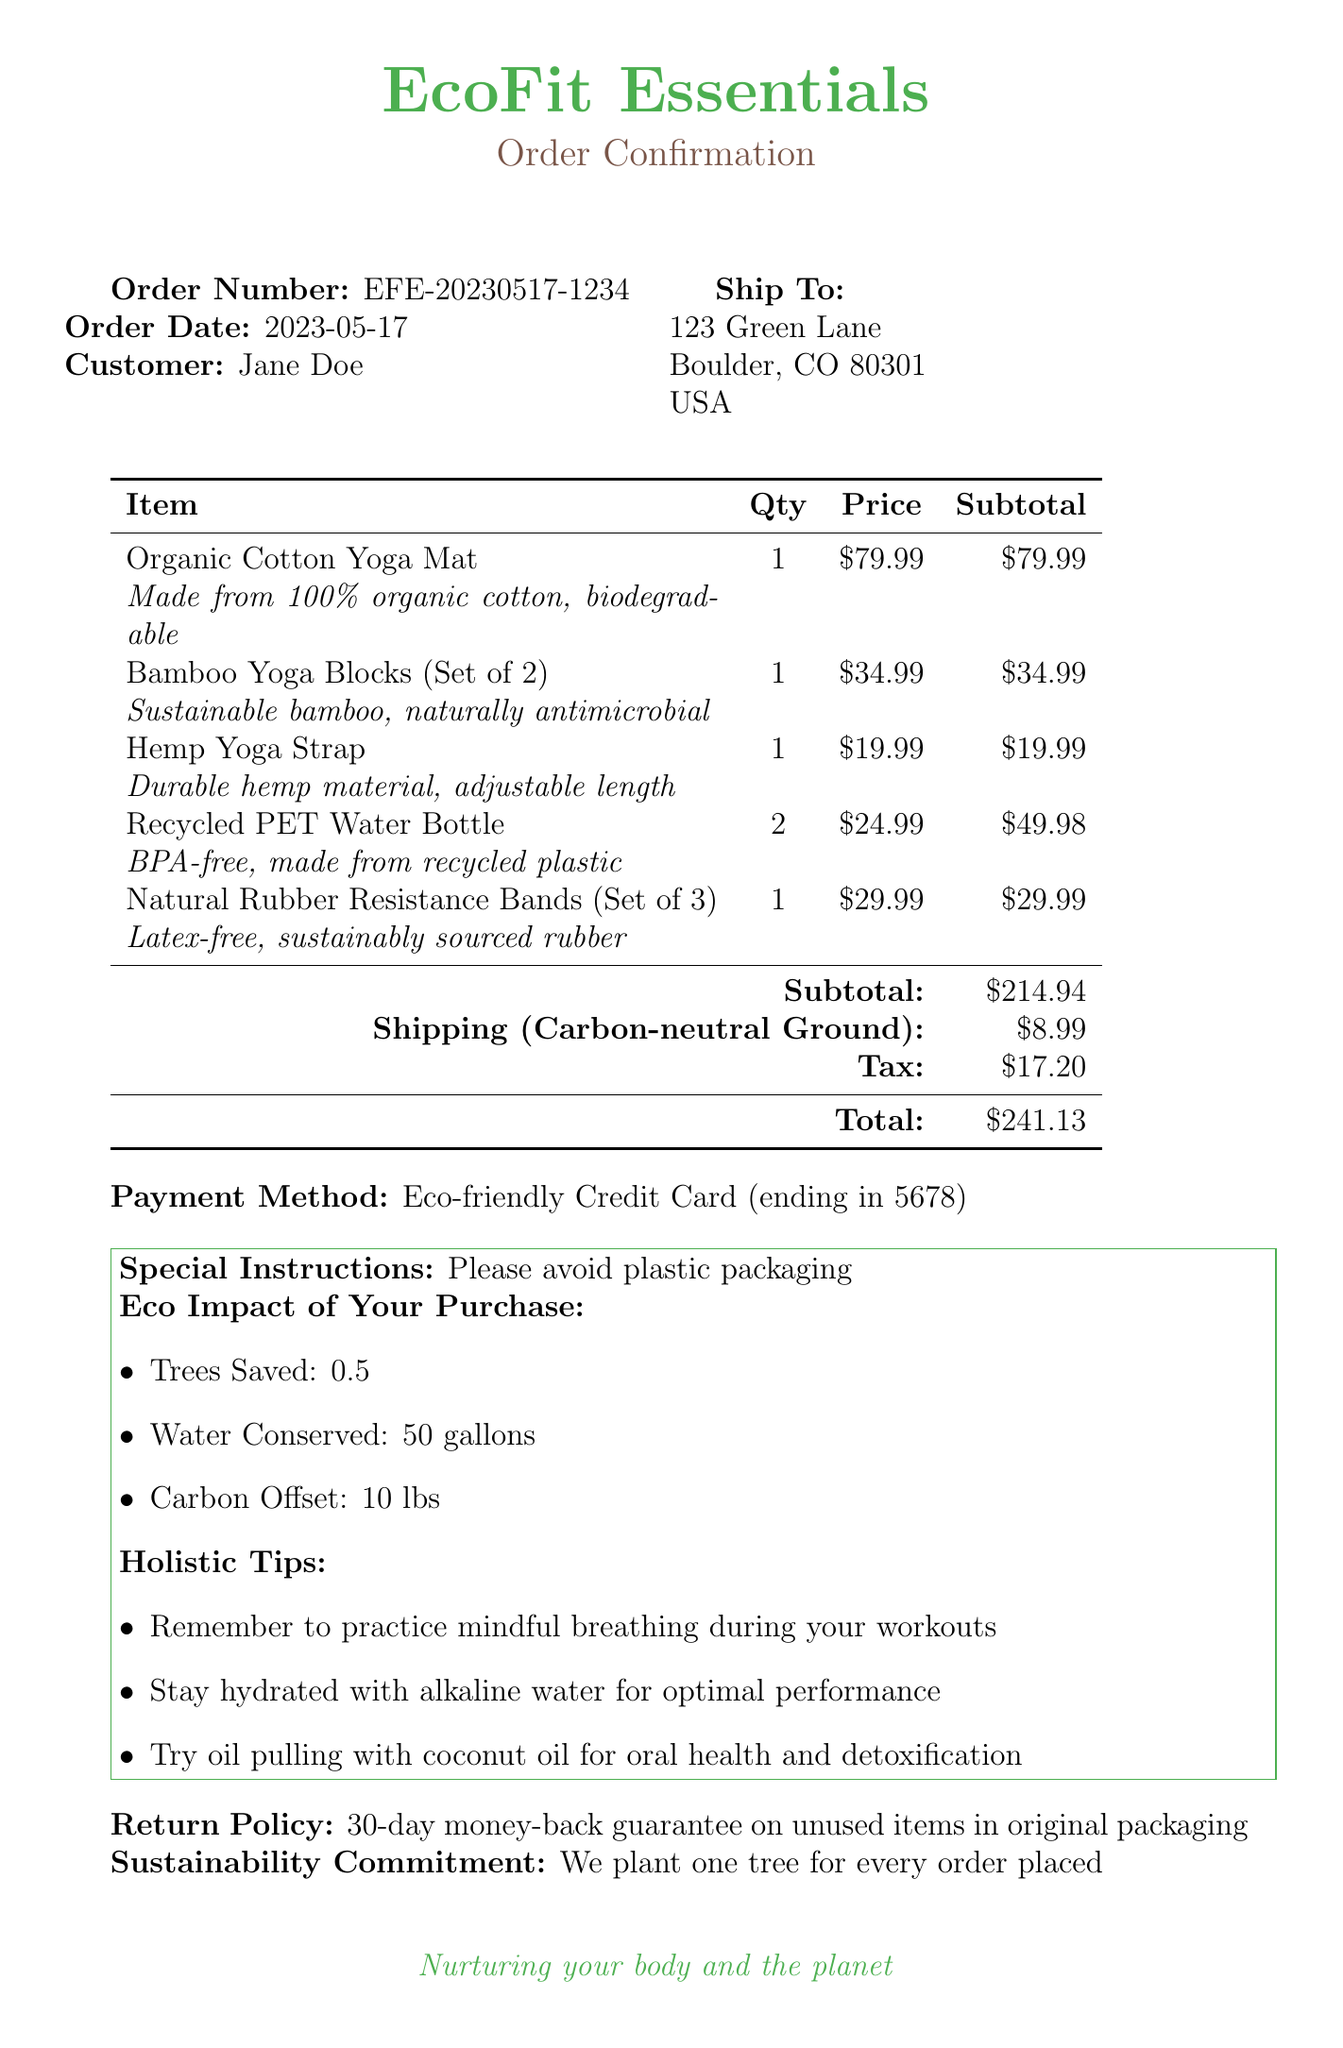What is the company name? The company name is listed at the top of the document.
Answer: EcoFit Essentials What is the order number? The order number is provided in the order confirmation section.
Answer: EFE-20230517-1234 What is the shipping cost? The shipping cost is detailed in the financial summary section.
Answer: $8.99 What was the subtotal of the order? The subtotal is specified in the itemization of costs.
Answer: $214.94 What is the total amount charged? The total amount charged is listed at the bottom of the financial summary.
Answer: $241.13 What special instruction was given? The document includes a section for special instructions.
Answer: Please avoid plastic packaging How many trees are saved with this purchase? The eco impact section indicates the environmental benefits.
Answer: 0.5 What is the return policy? The return policy is stated explicitly in the document.
Answer: 30-day money-back guarantee on unused items in original packaging What discount is applied for the next order? The promotional offer is highlighted in the promotional section.
Answer: 10% off your next order What holistic tip is given for workouts? The holistic tips section provides suggestions for better performance.
Answer: Remember to practice mindful breathing during your workouts 